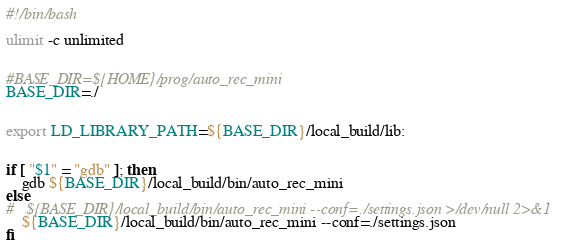<code> <loc_0><loc_0><loc_500><loc_500><_Bash_>#!/bin/bash

ulimit -c unlimited


#BASE_DIR=${HOME}/prog/auto_rec_mini
BASE_DIR=./


export LD_LIBRARY_PATH=${BASE_DIR}/local_build/lib:


if [ "$1" = "gdb" ]; then
	gdb ${BASE_DIR}/local_build/bin/auto_rec_mini
else
#	${BASE_DIR}/local_build/bin/auto_rec_mini --conf=./settings.json >/dev/null 2>&1
	${BASE_DIR}/local_build/bin/auto_rec_mini --conf=./settings.json
fi
</code> 